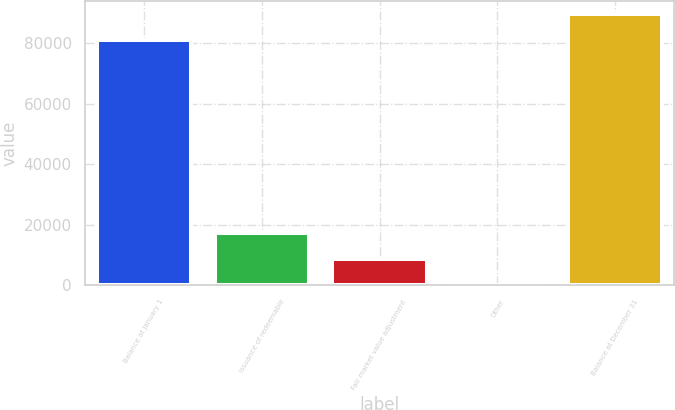Convert chart to OTSL. <chart><loc_0><loc_0><loc_500><loc_500><bar_chart><fcel>Balance at January 1<fcel>Issuance of redeemable<fcel>Fair market value adjustment<fcel>Other<fcel>Balance at December 31<nl><fcel>81076<fcel>17293.8<fcel>8686.4<fcel>79<fcel>89683.4<nl></chart> 